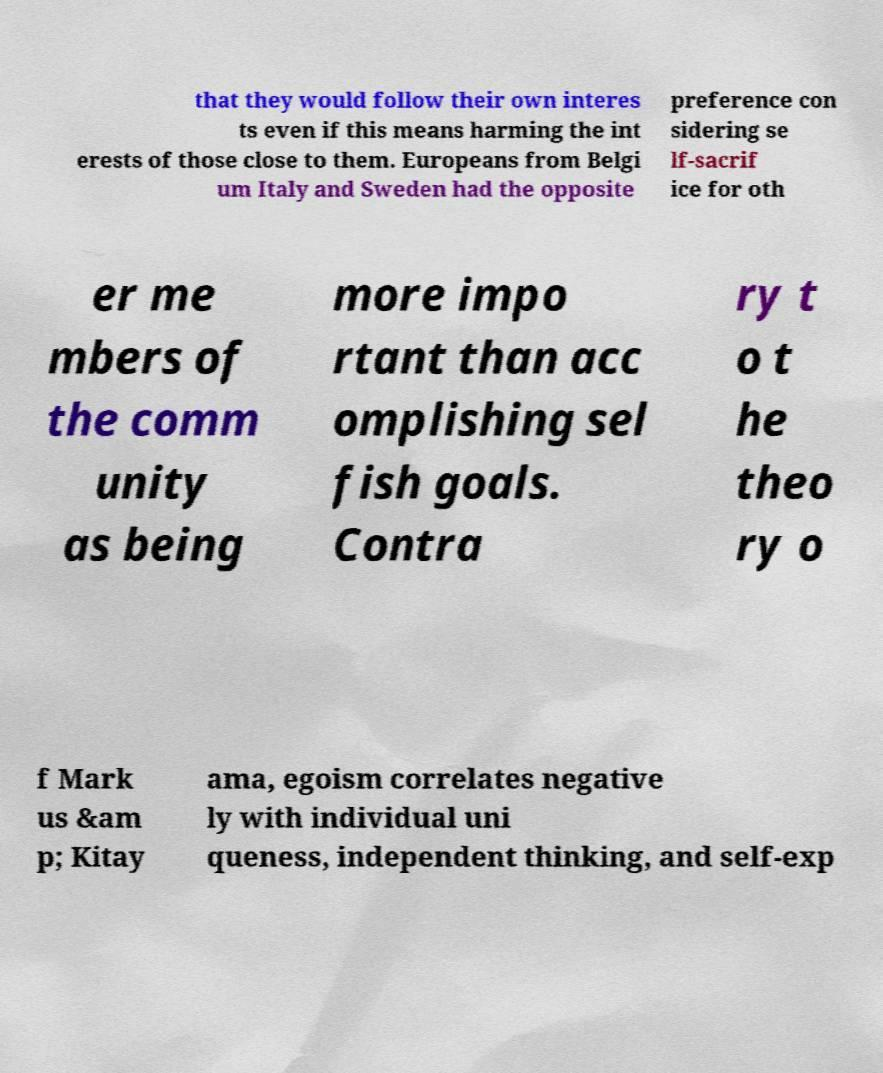Can you accurately transcribe the text from the provided image for me? that they would follow their own interes ts even if this means harming the int erests of those close to them. Europeans from Belgi um Italy and Sweden had the opposite preference con sidering se lf-sacrif ice for oth er me mbers of the comm unity as being more impo rtant than acc omplishing sel fish goals. Contra ry t o t he theo ry o f Mark us &am p; Kitay ama, egoism correlates negative ly with individual uni queness, independent thinking, and self-exp 